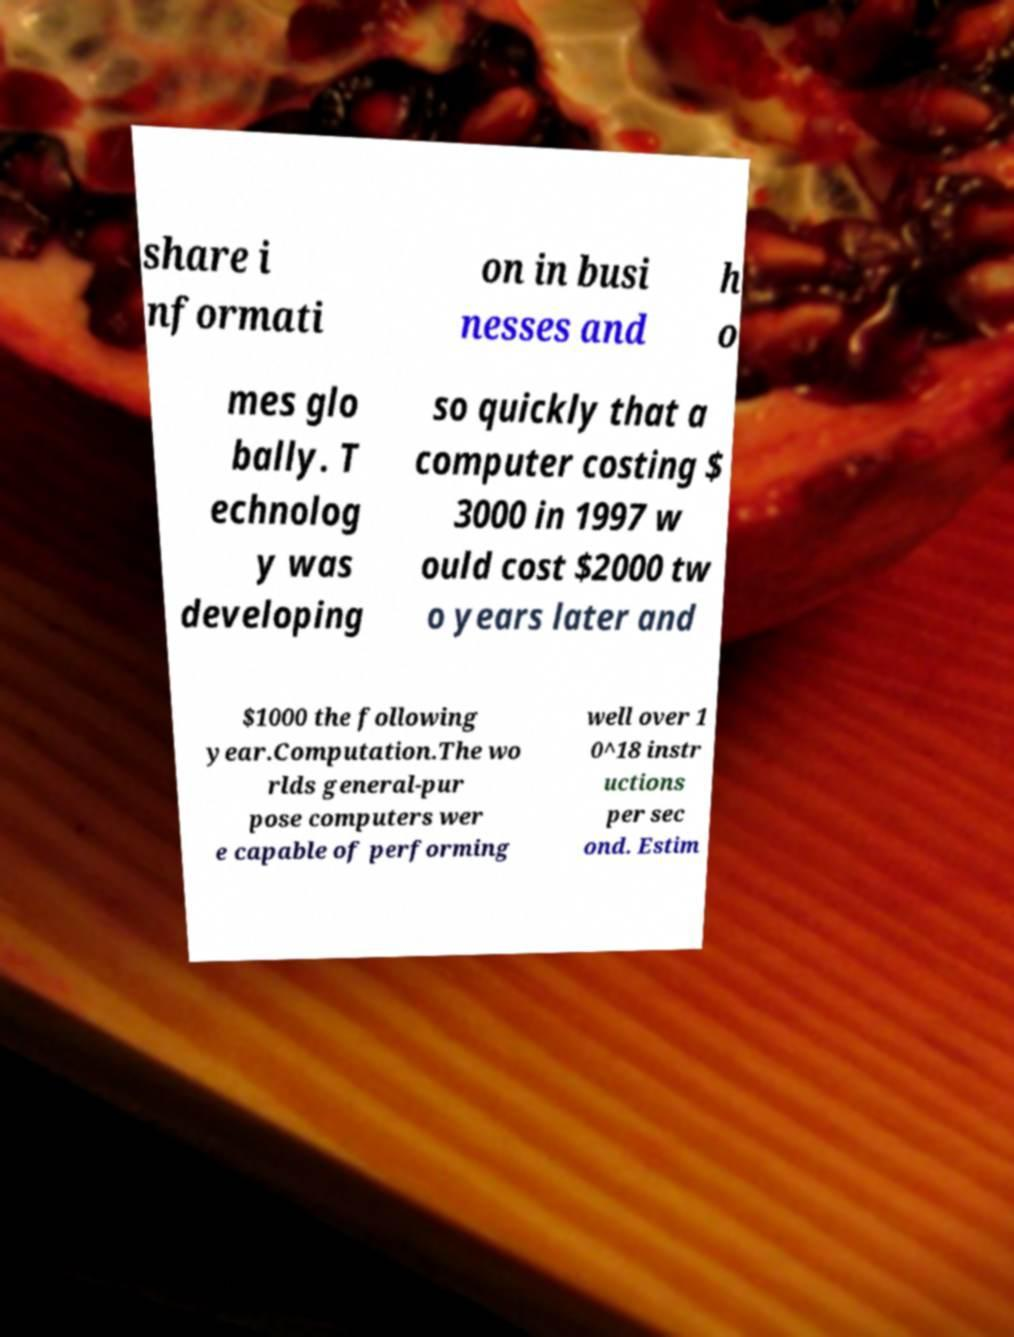For documentation purposes, I need the text within this image transcribed. Could you provide that? share i nformati on in busi nesses and h o mes glo bally. T echnolog y was developing so quickly that a computer costing $ 3000 in 1997 w ould cost $2000 tw o years later and $1000 the following year.Computation.The wo rlds general-pur pose computers wer e capable of performing well over 1 0^18 instr uctions per sec ond. Estim 